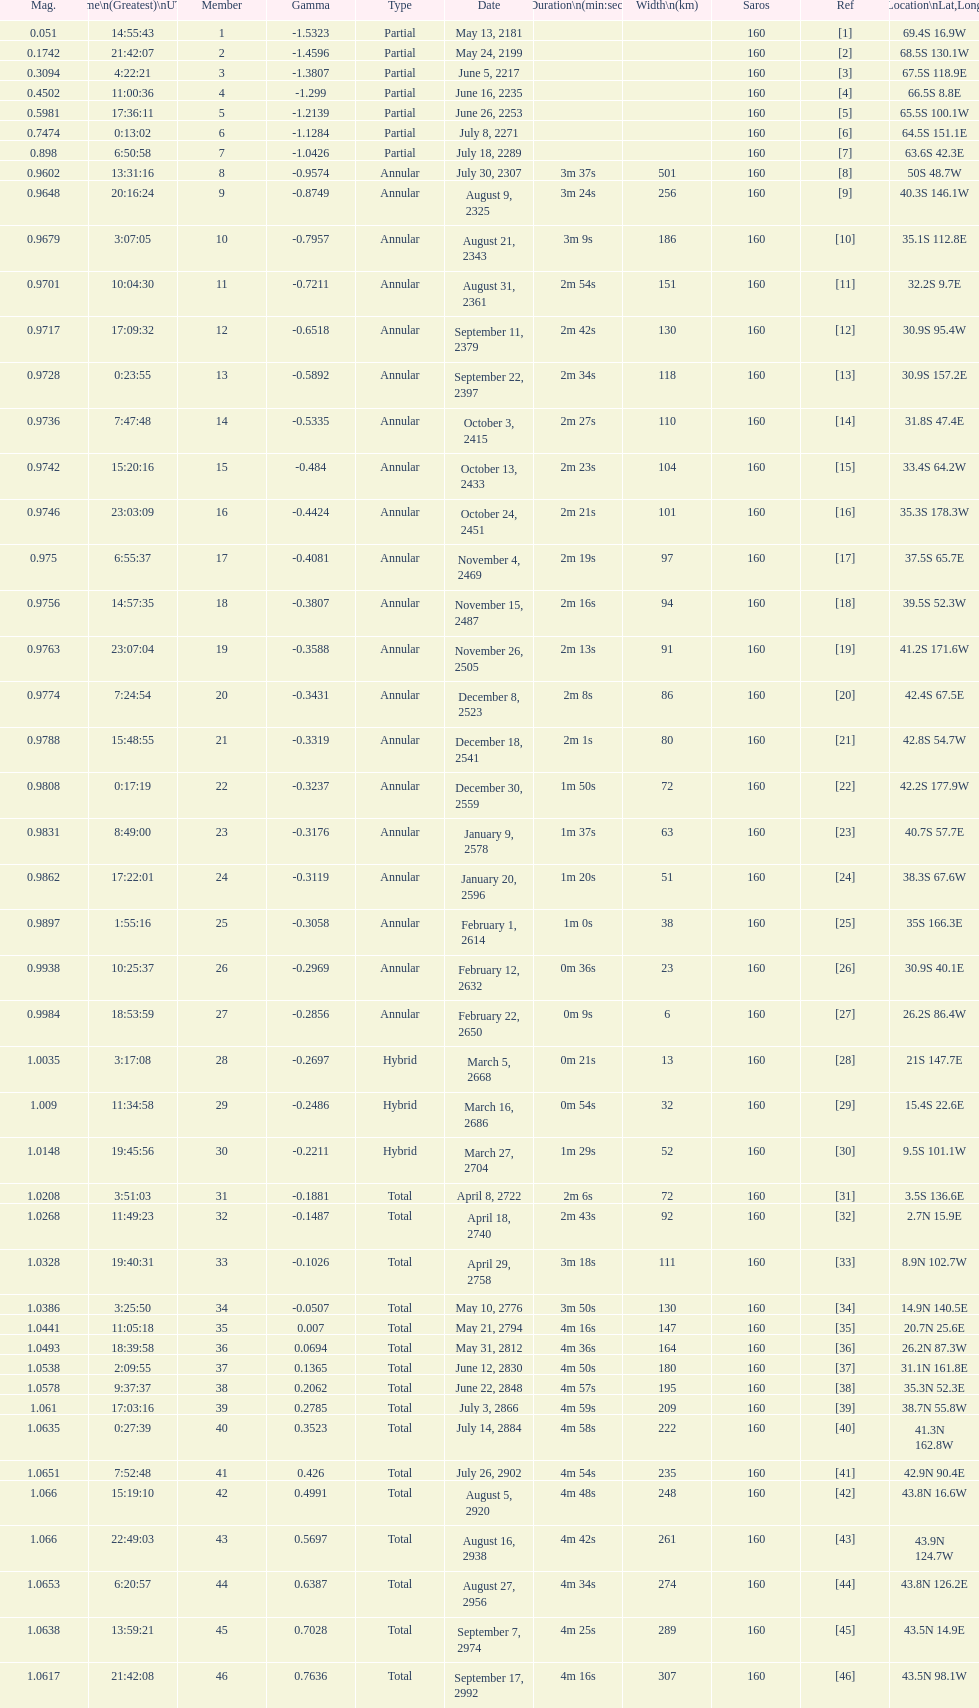What is the difference in magnitude between the may 13, 2181 solar saros and the may 24, 2199 solar saros? 0.1232. 